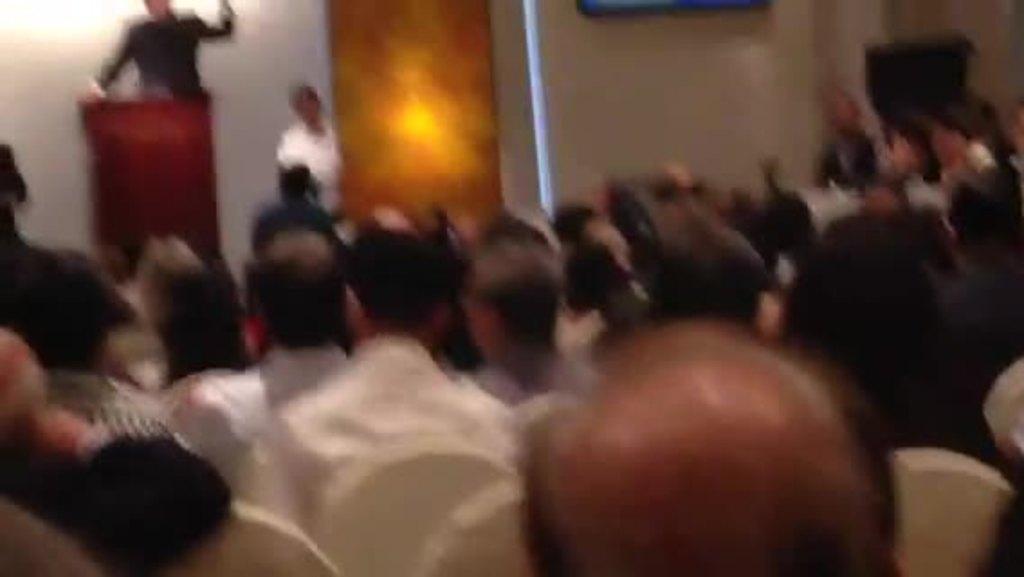Can you describe this image briefly? In the center of the image we can see a group of people are sitting on the chairs. On the left side of the image we can see a man is standing in-front of podium. In the background of the image we can see some persons, wall, light, pole. 